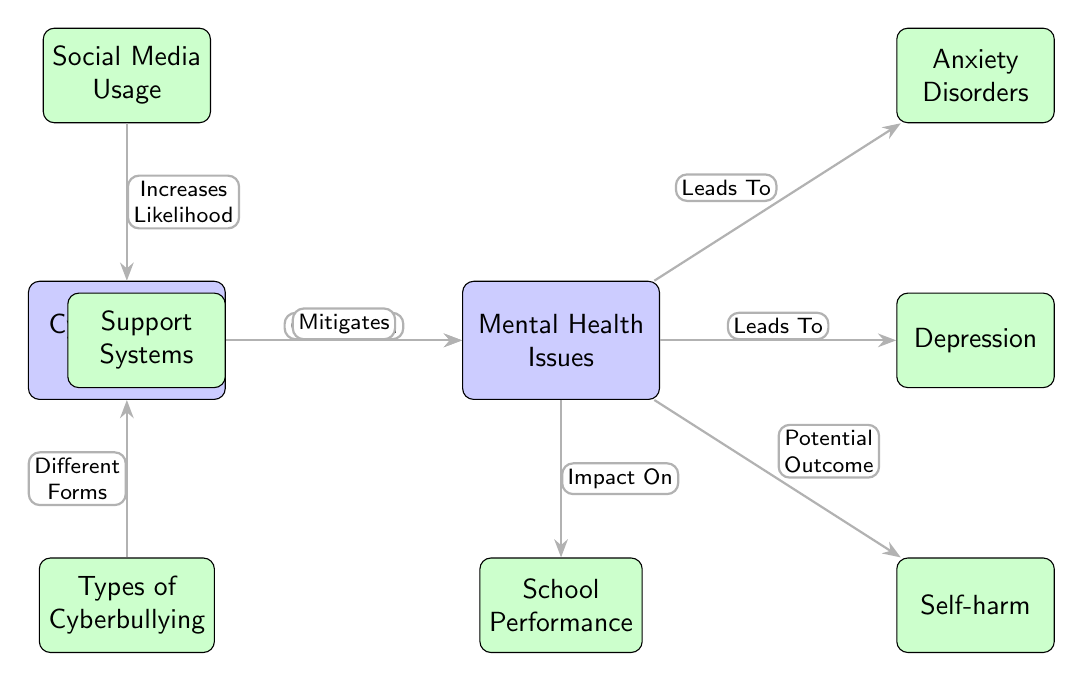What do the two main nodes represent? The two main nodes in the diagram represent "Cyberbullying Incidents" and "Mental Health Issues".
Answer: Cyberbullying Incidents, Mental Health Issues How many sub-nodes are connected to the "Mental Health Issues" node? There are four sub-nodes connected to the "Mental Health Issues" node: Anxiety Disorders, Depression, Self-harm, and School Performance.
Answer: 4 What is the correlation indicated between "Cyberbullying Incidents" and "Mental Health Issues"? The diagram indicates a "Correlation" between "Cyberbullying Incidents" and "Mental Health Issues".
Answer: Correlation What external factor increases the likelihood of "Cyberbullying Incidents"? "Social Media Usage" increases the likelihood of "Cyberbullying Incidents" according to the diagram.
Answer: Social Media Usage Which sub-node is said to mitigate "Mental Health Issues"? The sub-node "Support Systems" is stated to "Mitigates" "Mental Health Issues".
Answer: Support Systems What is one potential outcome of "Mental Health Issues"? The potential outcome of "Mental Health Issues" indicated in the diagram is "Self-harm".
Answer: Self-harm How does "Types of Cyberbullying" relate to "Cyberbullying Incidents"? The diagram shows that "Types of Cyberbullying" leads to "Different Forms" of "Cyberbullying Incidents".
Answer: Different Forms Which mental health issue is directly connected to the "Mental Health Issues" node? Both "Anxiety Disorders" and "Depression" are directly connected to the "Mental Health Issues" node.
Answer: Anxiety Disorders, Depression What impact do "Mental Health Issues" have on "School Performance"? The diagram illustrates that "Mental Health Issues" have an impact on "School Performance".
Answer: Impact On 